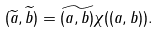<formula> <loc_0><loc_0><loc_500><loc_500>( \widetilde { a } , \widetilde { b } ) = \widetilde { ( a , b ) } \chi ( ( a , b ) ) .</formula> 